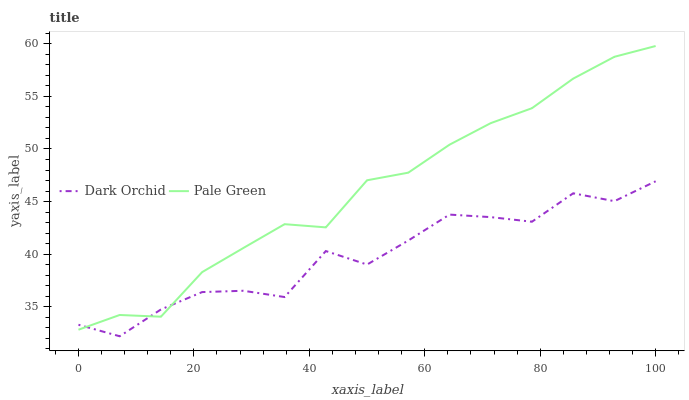Does Dark Orchid have the minimum area under the curve?
Answer yes or no. Yes. Does Pale Green have the maximum area under the curve?
Answer yes or no. Yes. Does Dark Orchid have the maximum area under the curve?
Answer yes or no. No. Is Pale Green the smoothest?
Answer yes or no. Yes. Is Dark Orchid the roughest?
Answer yes or no. Yes. Is Dark Orchid the smoothest?
Answer yes or no. No. Does Dark Orchid have the lowest value?
Answer yes or no. Yes. Does Pale Green have the highest value?
Answer yes or no. Yes. Does Dark Orchid have the highest value?
Answer yes or no. No. Does Pale Green intersect Dark Orchid?
Answer yes or no. Yes. Is Pale Green less than Dark Orchid?
Answer yes or no. No. Is Pale Green greater than Dark Orchid?
Answer yes or no. No. 